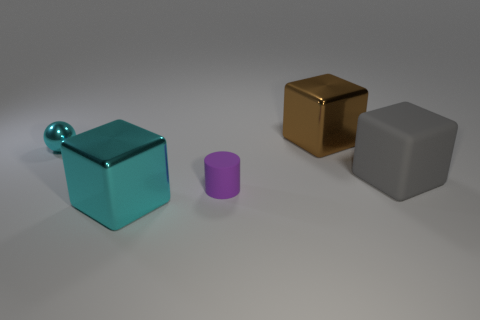Add 1 large gray things. How many objects exist? 6 Subtract all balls. How many objects are left? 4 Subtract all cyan blocks. Subtract all shiny things. How many objects are left? 1 Add 5 shiny spheres. How many shiny spheres are left? 6 Add 1 brown shiny balls. How many brown shiny balls exist? 1 Subtract 0 blue blocks. How many objects are left? 5 